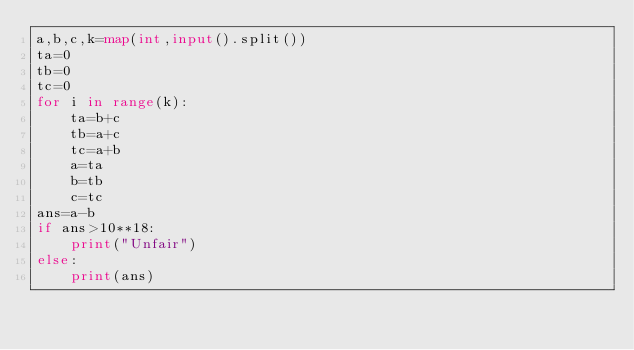Convert code to text. <code><loc_0><loc_0><loc_500><loc_500><_Python_>a,b,c,k=map(int,input().split())
ta=0
tb=0
tc=0
for i in range(k):
    ta=b+c
    tb=a+c
    tc=a+b
    a=ta
    b=tb
    c=tc
ans=a-b
if ans>10**18:
    print("Unfair")
else:
    print(ans)</code> 